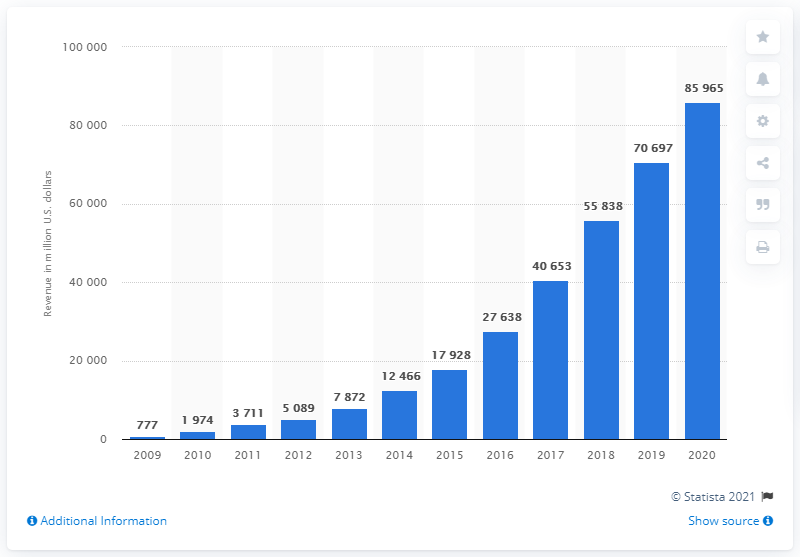Outline some significant characteristics in this image. Facebook generated revenue of 706,978 in the previous fiscal year. In 2020, Facebook generated a total revenue of 859,650,000. 